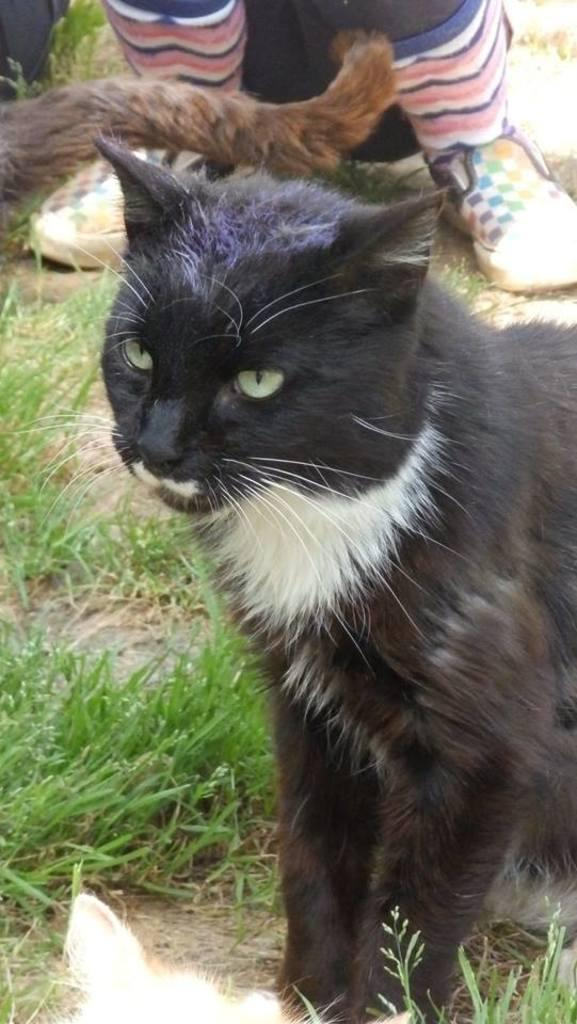What types of living organisms can be seen in the image? There are animals in the image. What type of vegetation is present in the image? There is grass in the image. Can you describe the lower part of a person's body that is visible in the image? There are person legs with footwear in the image. What type of bird is sitting on the wren in the image? There is no wren present in the image, as the provided facts only mention animals and grass. 